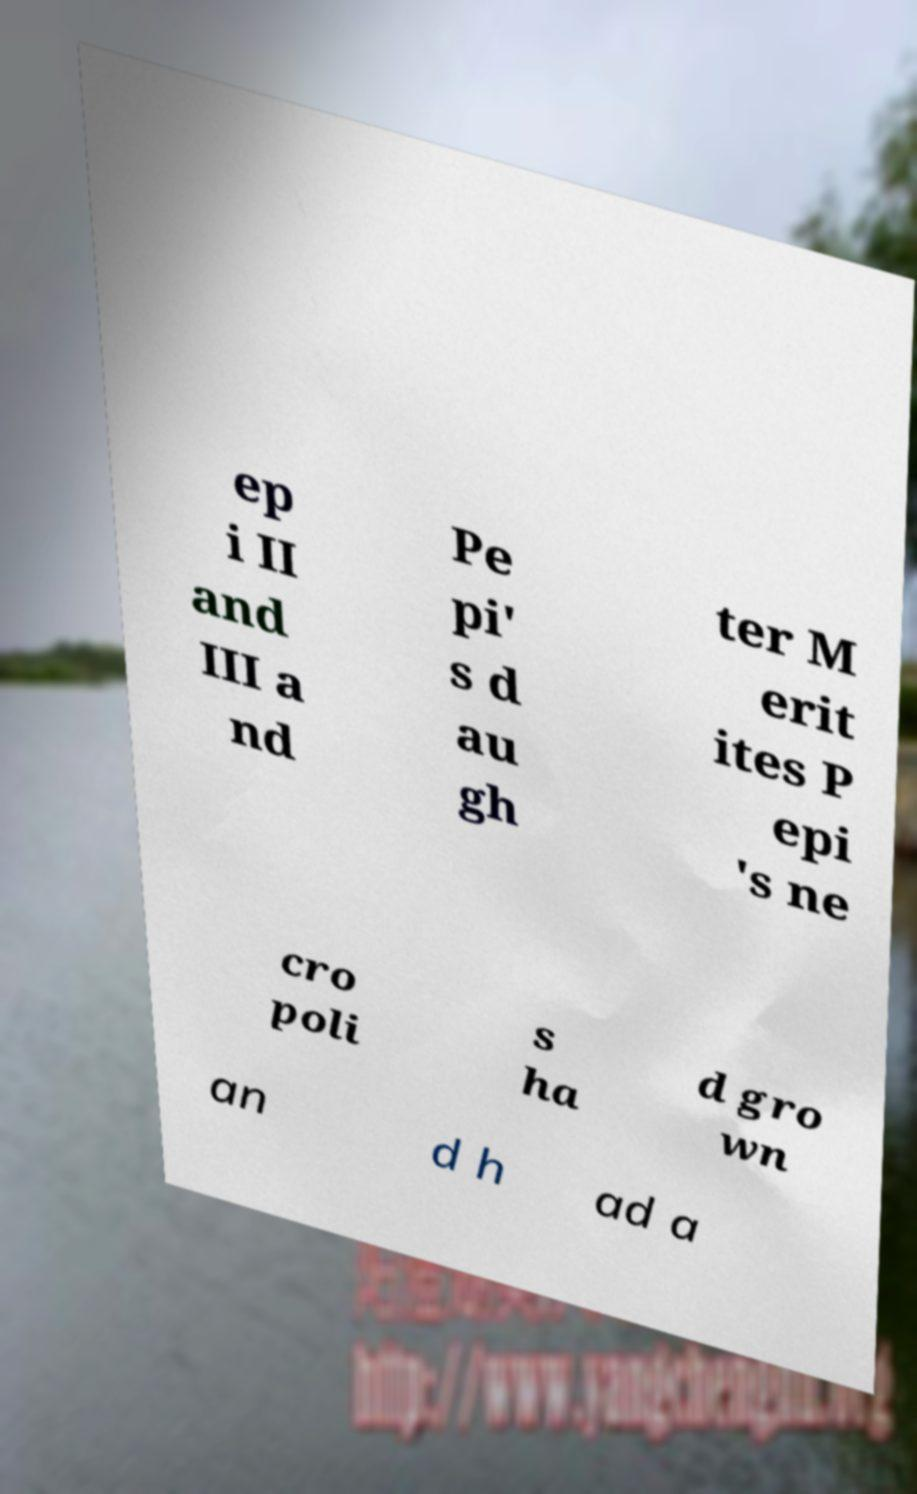Please identify and transcribe the text found in this image. ep i II and III a nd Pe pi' s d au gh ter M erit ites P epi 's ne cro poli s ha d gro wn an d h ad a 